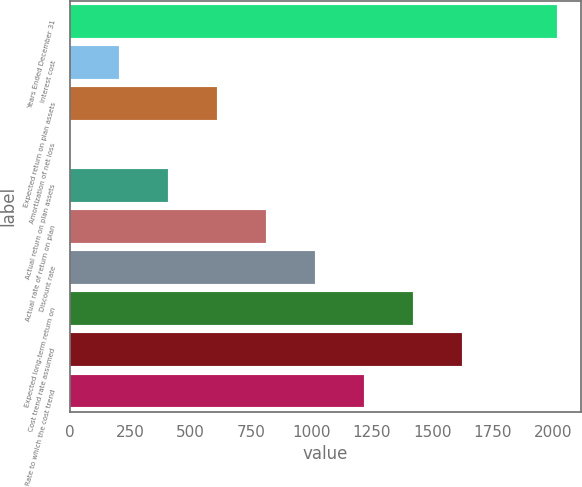<chart> <loc_0><loc_0><loc_500><loc_500><bar_chart><fcel>Years Ended December 31<fcel>Interest cost<fcel>Expected return on plan assets<fcel>Amortization of net loss<fcel>Actual return on plan assets<fcel>Actual rate of return on plan<fcel>Discount rate<fcel>Expected long-term return on<fcel>Cost trend rate assumed<fcel>Rate to which the cost trend<nl><fcel>2017<fcel>203.6<fcel>608.8<fcel>1<fcel>406.2<fcel>811.4<fcel>1014<fcel>1419.2<fcel>1621.8<fcel>1216.6<nl></chart> 